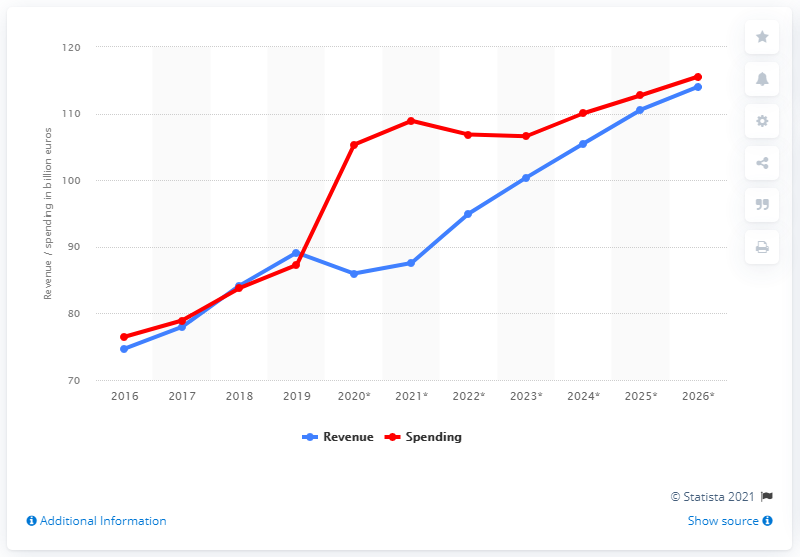Highlight a few significant elements in this photo. In 2019, Ireland's government spending totaled 87.58%. In 2019, the government revenue in Ireland was approximately 89.14. 